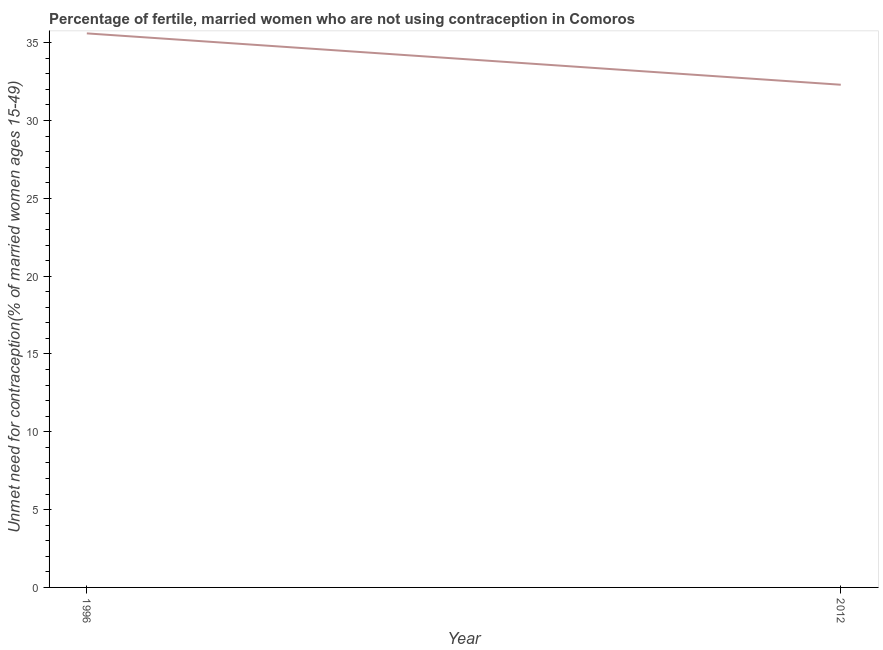What is the number of married women who are not using contraception in 2012?
Make the answer very short. 32.3. Across all years, what is the maximum number of married women who are not using contraception?
Offer a terse response. 35.6. Across all years, what is the minimum number of married women who are not using contraception?
Keep it short and to the point. 32.3. What is the sum of the number of married women who are not using contraception?
Ensure brevity in your answer.  67.9. What is the difference between the number of married women who are not using contraception in 1996 and 2012?
Give a very brief answer. 3.3. What is the average number of married women who are not using contraception per year?
Your answer should be very brief. 33.95. What is the median number of married women who are not using contraception?
Provide a succinct answer. 33.95. Do a majority of the years between 1996 and 2012 (inclusive) have number of married women who are not using contraception greater than 27 %?
Offer a terse response. Yes. What is the ratio of the number of married women who are not using contraception in 1996 to that in 2012?
Give a very brief answer. 1.1. Is the number of married women who are not using contraception in 1996 less than that in 2012?
Offer a very short reply. No. Does the number of married women who are not using contraception monotonically increase over the years?
Offer a very short reply. No. How many years are there in the graph?
Offer a very short reply. 2. What is the difference between two consecutive major ticks on the Y-axis?
Ensure brevity in your answer.  5. Does the graph contain any zero values?
Ensure brevity in your answer.  No. What is the title of the graph?
Provide a short and direct response. Percentage of fertile, married women who are not using contraception in Comoros. What is the label or title of the Y-axis?
Ensure brevity in your answer.   Unmet need for contraception(% of married women ages 15-49). What is the  Unmet need for contraception(% of married women ages 15-49) of 1996?
Provide a succinct answer. 35.6. What is the  Unmet need for contraception(% of married women ages 15-49) in 2012?
Offer a very short reply. 32.3. What is the ratio of the  Unmet need for contraception(% of married women ages 15-49) in 1996 to that in 2012?
Give a very brief answer. 1.1. 